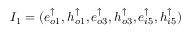Convert formula to latex. <formula><loc_0><loc_0><loc_500><loc_500>I _ { 1 } = ( e _ { o 1 } ^ { \uparrow } , h _ { o 1 } ^ { \uparrow } , e _ { o 3 } ^ { \uparrow } , h _ { o 3 } ^ { \uparrow } , e _ { i 5 } ^ { \uparrow } , h _ { i 5 } ^ { \uparrow } )</formula> 